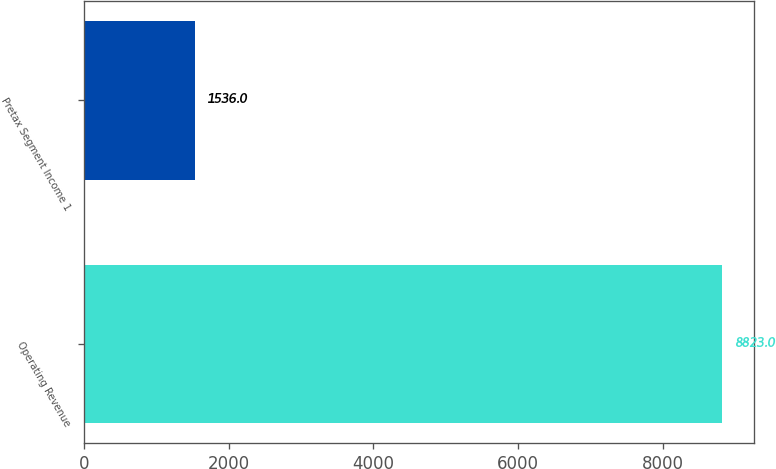<chart> <loc_0><loc_0><loc_500><loc_500><bar_chart><fcel>Operating Revenue<fcel>Pretax Segment Income 1<nl><fcel>8823<fcel>1536<nl></chart> 